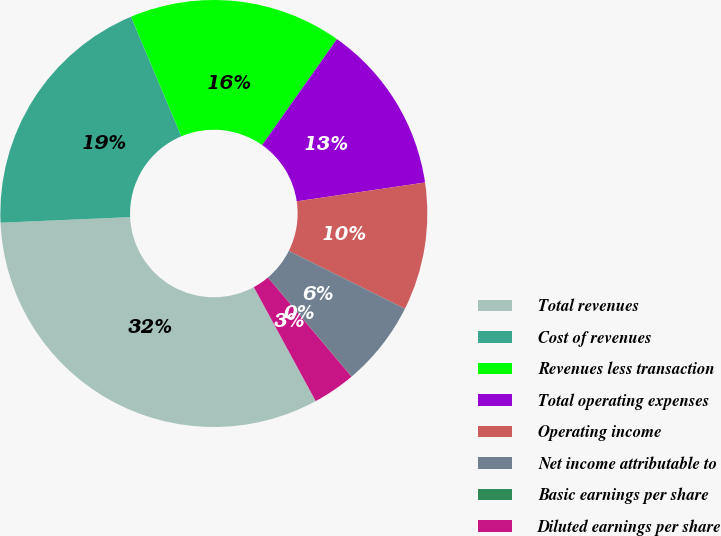Convert chart. <chart><loc_0><loc_0><loc_500><loc_500><pie_chart><fcel>Total revenues<fcel>Cost of revenues<fcel>Revenues less transaction<fcel>Total operating expenses<fcel>Operating income<fcel>Net income attributable to<fcel>Basic earnings per share<fcel>Diluted earnings per share<nl><fcel>32.23%<fcel>19.35%<fcel>16.12%<fcel>12.9%<fcel>9.68%<fcel>6.46%<fcel>0.02%<fcel>3.24%<nl></chart> 